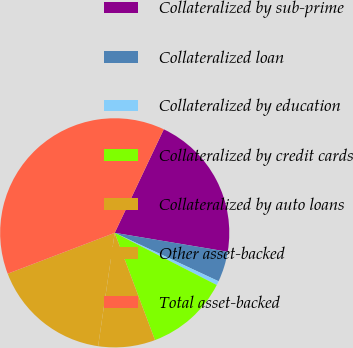Convert chart. <chart><loc_0><loc_0><loc_500><loc_500><pie_chart><fcel>Collateralized by sub-prime<fcel>Collateralized loan<fcel>Collateralized by education<fcel>Collateralized by credit cards<fcel>Collateralized by auto loans<fcel>Other asset-backed<fcel>Total asset-backed<nl><fcel>20.6%<fcel>4.3%<fcel>0.58%<fcel>11.76%<fcel>8.03%<fcel>16.88%<fcel>37.85%<nl></chart> 